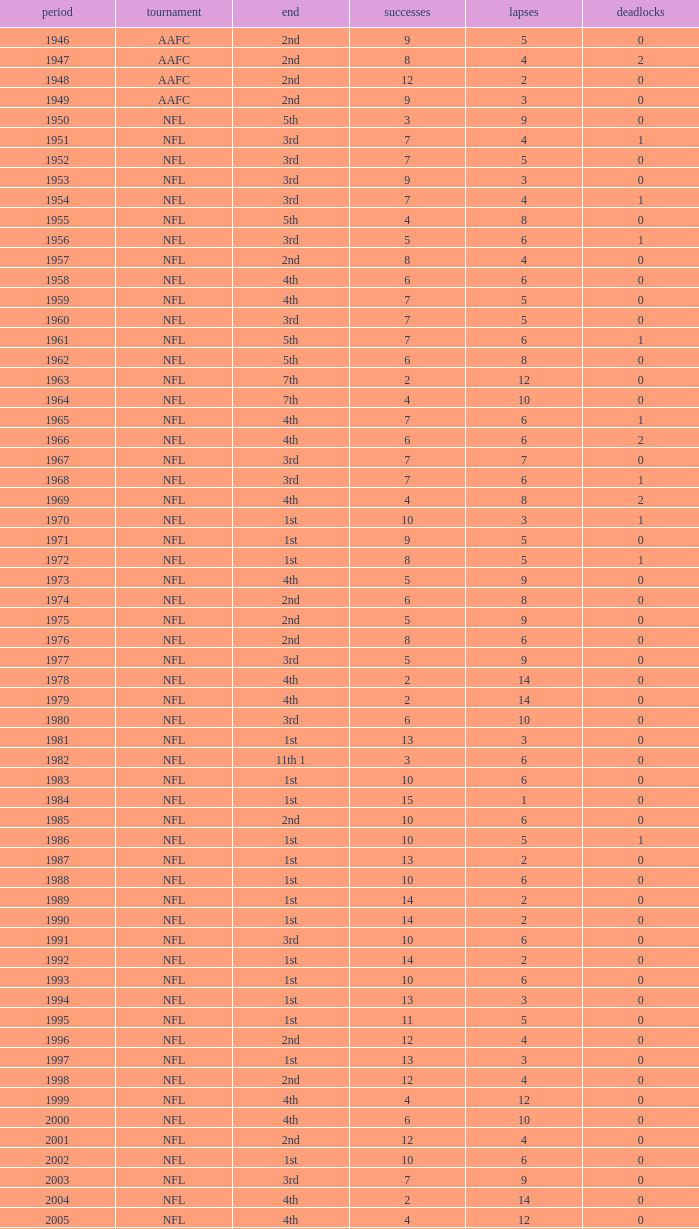What is the number of losses when the ties are lesser than 0? 0.0. 